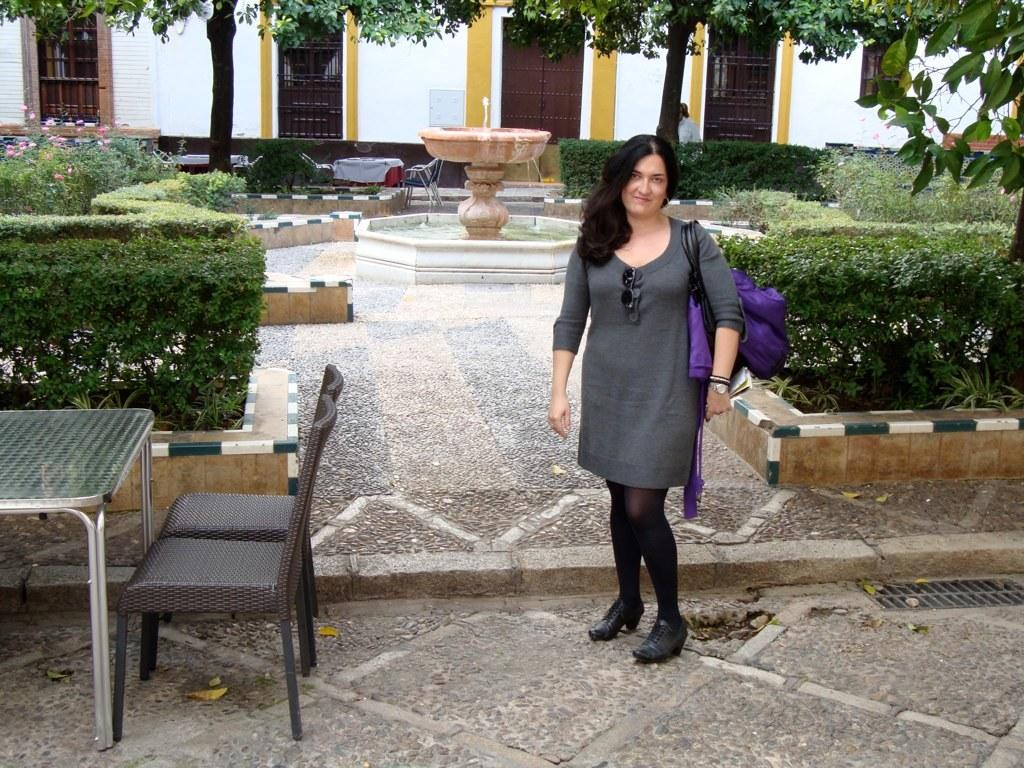What is the main subject of the image? There is a person standing in the image. What furniture is visible on the left side of the image? There is a table and chairs on the left side of the image. What type of water feature can be seen in the image? There is a fountain in the image. What type of vegetation is present in the image? There are trees in the image. What type of structure is visible in the background of the image? There is a building in the background of the image. What features can be seen on the building? The building has a door and windows. How many goldfish are swimming in the fountain in the image? There are no goldfish visible in the fountain in the image. What is the value of the peace treaty signed in the image? There is no peace treaty or any indication of a value in the image. 